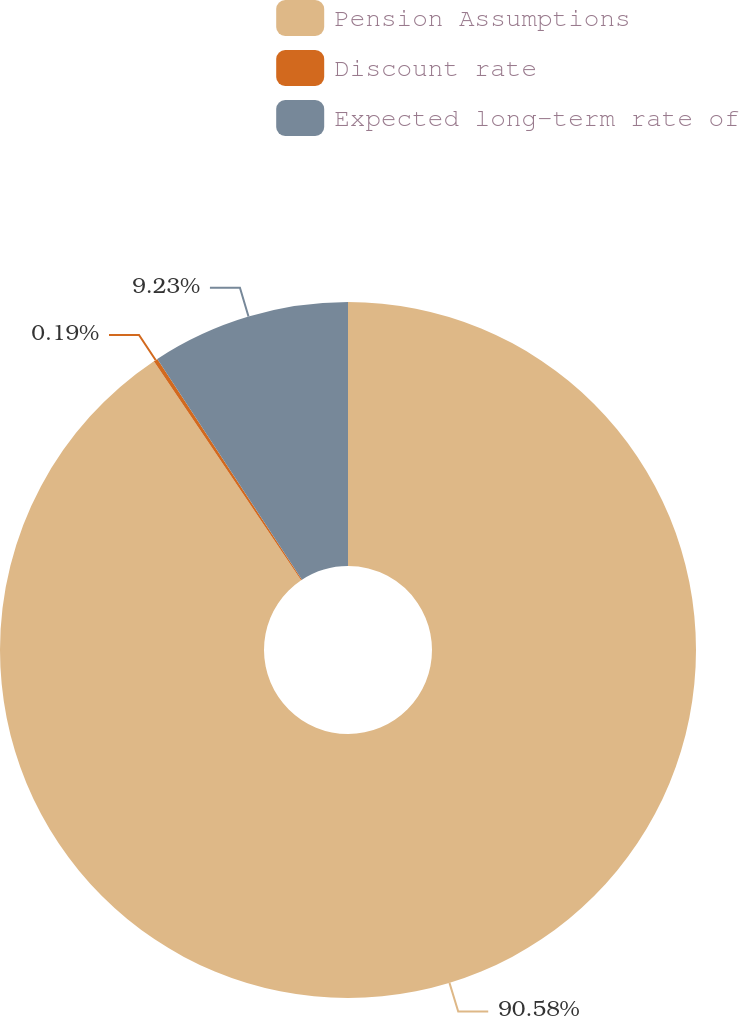<chart> <loc_0><loc_0><loc_500><loc_500><pie_chart><fcel>Pension Assumptions<fcel>Discount rate<fcel>Expected long-term rate of<nl><fcel>90.59%<fcel>0.19%<fcel>9.23%<nl></chart> 